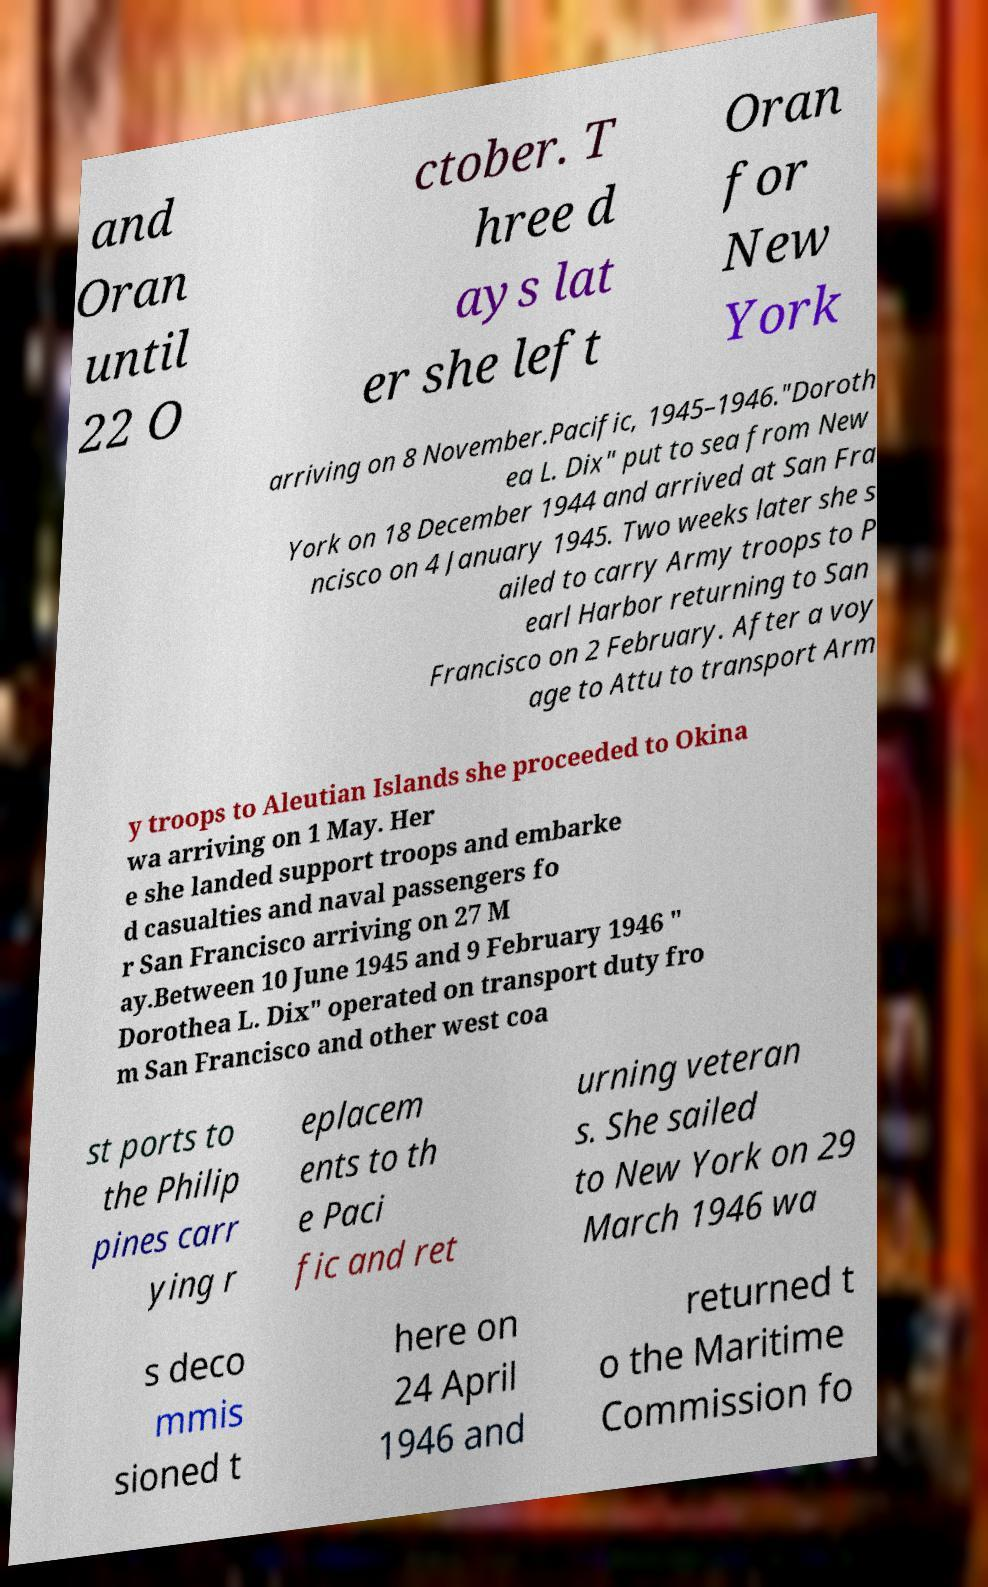Can you read and provide the text displayed in the image?This photo seems to have some interesting text. Can you extract and type it out for me? and Oran until 22 O ctober. T hree d ays lat er she left Oran for New York arriving on 8 November.Pacific, 1945–1946."Doroth ea L. Dix" put to sea from New York on 18 December 1944 and arrived at San Fra ncisco on 4 January 1945. Two weeks later she s ailed to carry Army troops to P earl Harbor returning to San Francisco on 2 February. After a voy age to Attu to transport Arm y troops to Aleutian Islands she proceeded to Okina wa arriving on 1 May. Her e she landed support troops and embarke d casualties and naval passengers fo r San Francisco arriving on 27 M ay.Between 10 June 1945 and 9 February 1946 " Dorothea L. Dix" operated on transport duty fro m San Francisco and other west coa st ports to the Philip pines carr ying r eplacem ents to th e Paci fic and ret urning veteran s. She sailed to New York on 29 March 1946 wa s deco mmis sioned t here on 24 April 1946 and returned t o the Maritime Commission fo 